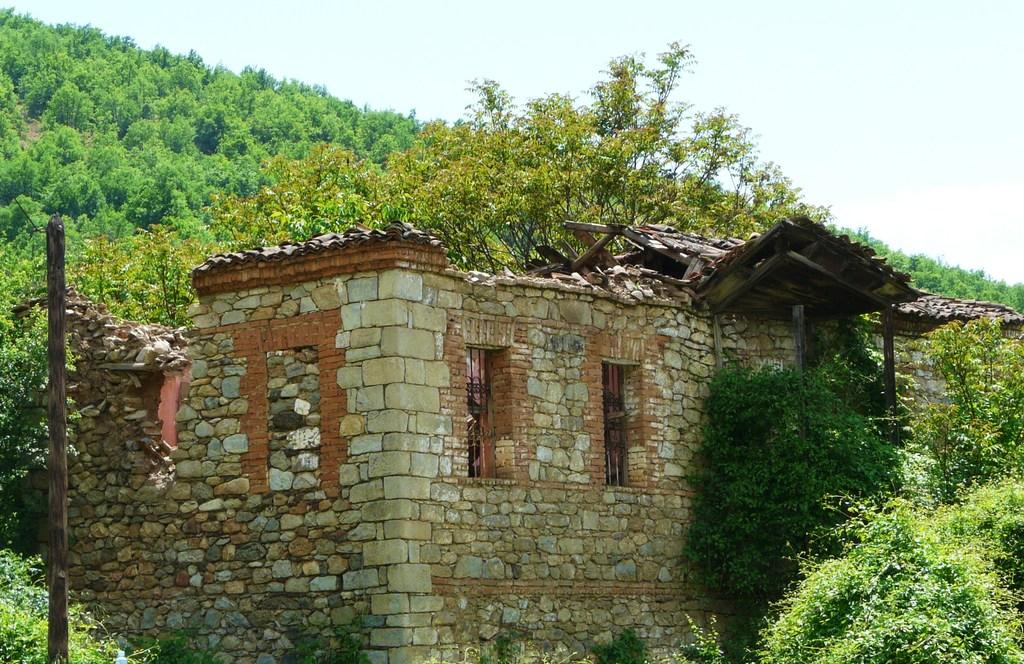What is the main subject in the center of the image? There is a cottage in the center of the image. What can be seen in the background of the image? There are trees in the background of the image. What is visible at the top of the image? The sky is visible at the top of the image. What type of fuel is being used by the cottage in the image? There is no information about the cottage's fuel source in the image, so it cannot be determined. 